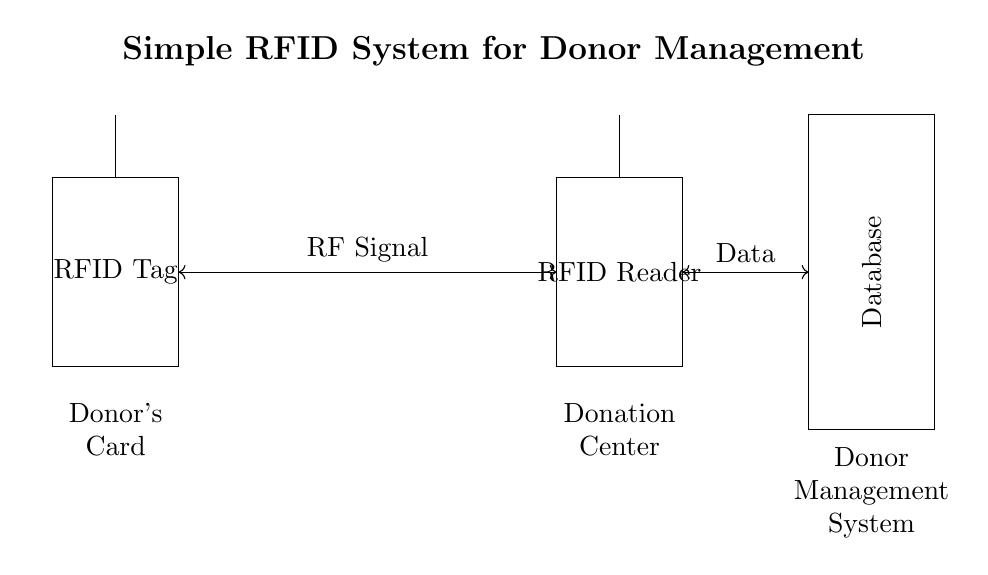What component represents the tag? The circuit diagram shows a rectangle labeled "RFID Tag," which signifies the component being used in the system.
Answer: RFID Tag What does the antenna in the RFID Tag do? The antenna is responsible for transmitting and receiving radio frequency signals, allowing it to communicate with the RFID Reader.
Answer: Transmit/Receive signals How many components are connected with RF Signal? There are two components, the RFID Tag and the RFID Reader, connected by a bi-directional arrow labeled "RF Signal."
Answer: Two What is the purpose of the database in the system? The database stores information related to donors and donations after data is transmitted from the RFID Reader.
Answer: Store donor information What type of connection is there between the RFID Reader and the Database? The connection is bi-directional and labeled "Data," indicating that information flows both ways between the RFID Reader and the Database.
Answer: Bi-directional data connection Why is the RFID system beneficial for donor management? The RFID system allows for efficient tracking and management of donations, as it automates data collection and minimizes human error.
Answer: Efficient tracking What is the relationship between the Donor's Card and the Donation Center? The Donor's Card, represented by the RFID Tag, communicates with the Donation Center through the RFID Reader to access donor information.
Answer: Communication for donor identification 